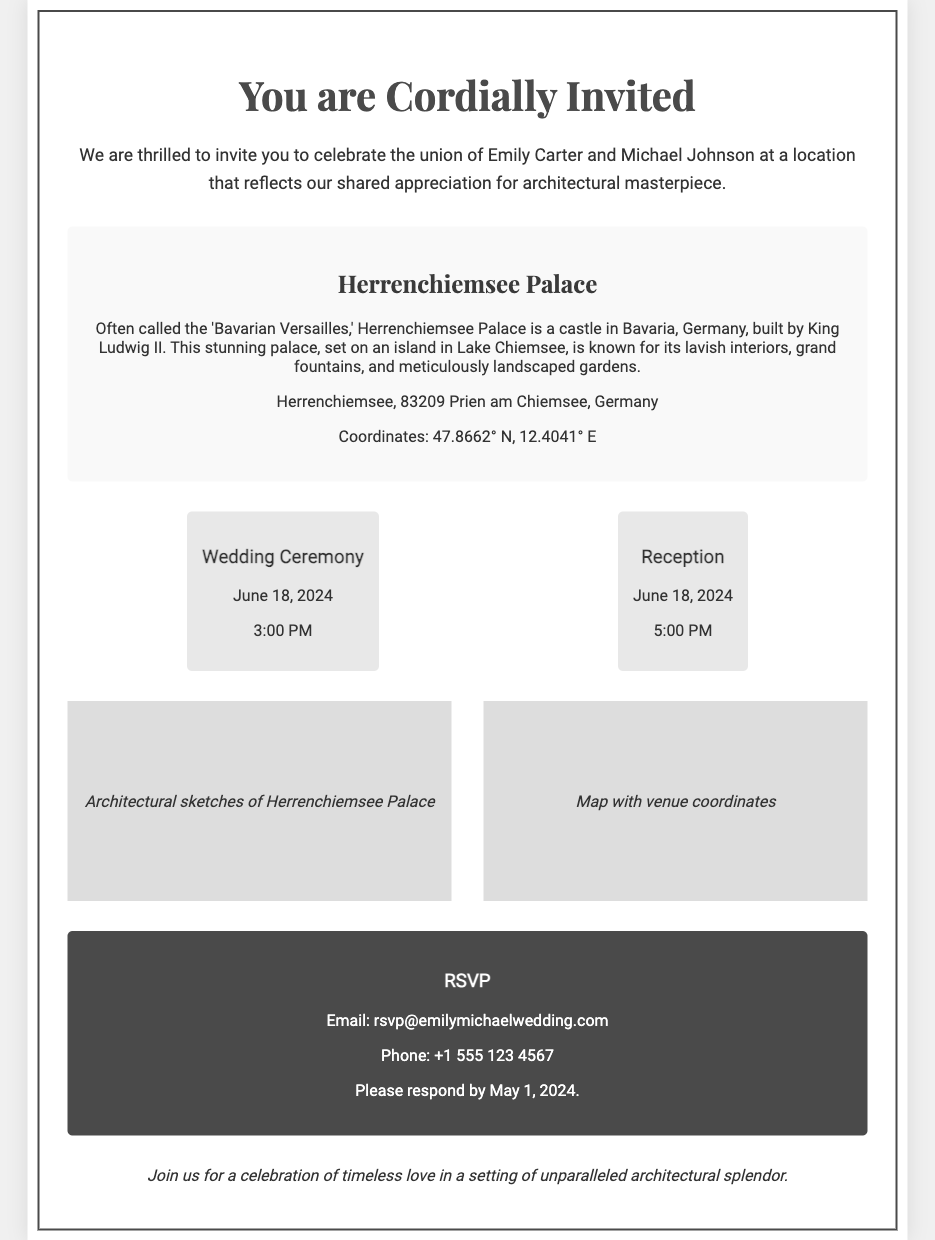What are the names of the couple? The invitation states the names of the couple getting married, which are Emily Carter and Michael Johnson.
Answer: Emily Carter and Michael Johnson What is the wedding ceremony date? The invitation specifies the date of the wedding ceremony as June 18, 2024.
Answer: June 18, 2024 Where is the venue located? The invitation provides the venue's name and location, which is Herrenchiemsee Palace in Bavaria, Germany.
Answer: Herrenchiemsee Palace, Bavaria, Germany What time does the reception start? The invitation mentions that the reception begins at 5:00 PM on the same day as the ceremony.
Answer: 5:00 PM What is the RSVP deadline? The RSVP section of the invitation indicates that guests should respond by May 1, 2024.
Answer: May 1, 2024 What coordinates are provided for the venue? The invitation lists the geographic coordinates for Herrenchiemsee Palace as 47.8662° N, 12.4041° E.
Answer: 47.8662° N, 12.4041° E What type of architectural theme is emphasized in the invitation? The invitation invites guests to celebrate in a location known for its architectural brilliance, emphasizing a shared appreciation for architectural masterpieces.
Answer: Architectural brilliance What is included in the design elements of the invitation? The design elements include architectural sketches and a map with venue coordinates, reflecting the couple's appreciation for structural beauty.
Answer: Architectural sketches and map What is the phone number for RSVPs? The invitation provides a contact phone number for RSVPs, which is stated directly in the RSVP section.
Answer: +1 555 123 4567 